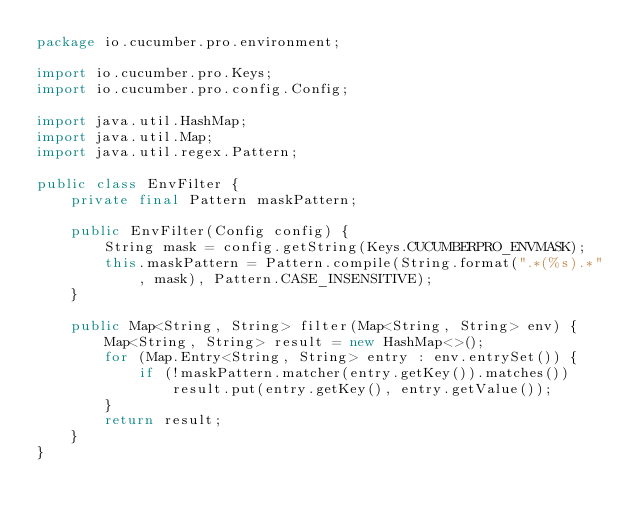<code> <loc_0><loc_0><loc_500><loc_500><_Java_>package io.cucumber.pro.environment;

import io.cucumber.pro.Keys;
import io.cucumber.pro.config.Config;

import java.util.HashMap;
import java.util.Map;
import java.util.regex.Pattern;

public class EnvFilter {
    private final Pattern maskPattern;

    public EnvFilter(Config config) {
        String mask = config.getString(Keys.CUCUMBERPRO_ENVMASK);
        this.maskPattern = Pattern.compile(String.format(".*(%s).*", mask), Pattern.CASE_INSENSITIVE);
    }

    public Map<String, String> filter(Map<String, String> env) {
        Map<String, String> result = new HashMap<>();
        for (Map.Entry<String, String> entry : env.entrySet()) {
            if (!maskPattern.matcher(entry.getKey()).matches())
                result.put(entry.getKey(), entry.getValue());
        }
        return result;
    }
}
</code> 